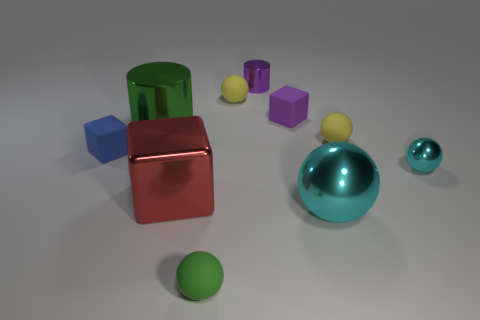Are there more big green metal cylinders behind the tiny purple metallic thing than red shiny cubes?
Your response must be concise. No. What is the small blue object made of?
Ensure brevity in your answer.  Rubber. How many gray cylinders are the same size as the red object?
Provide a short and direct response. 0. Is the number of tiny balls in front of the red metal cube the same as the number of large cyan objects to the left of the green cylinder?
Make the answer very short. No. Are the big cylinder and the tiny cylinder made of the same material?
Your response must be concise. Yes. Are there any large red cubes behind the tiny metallic object behind the tiny blue object?
Give a very brief answer. No. Is there another tiny metallic object that has the same shape as the tiny cyan object?
Offer a very short reply. No. Is the color of the tiny cylinder the same as the large metallic block?
Your answer should be compact. No. There is a purple cylinder that is behind the cube behind the tiny blue matte cube; what is its material?
Make the answer very short. Metal. What size is the shiny cube?
Your response must be concise. Large. 